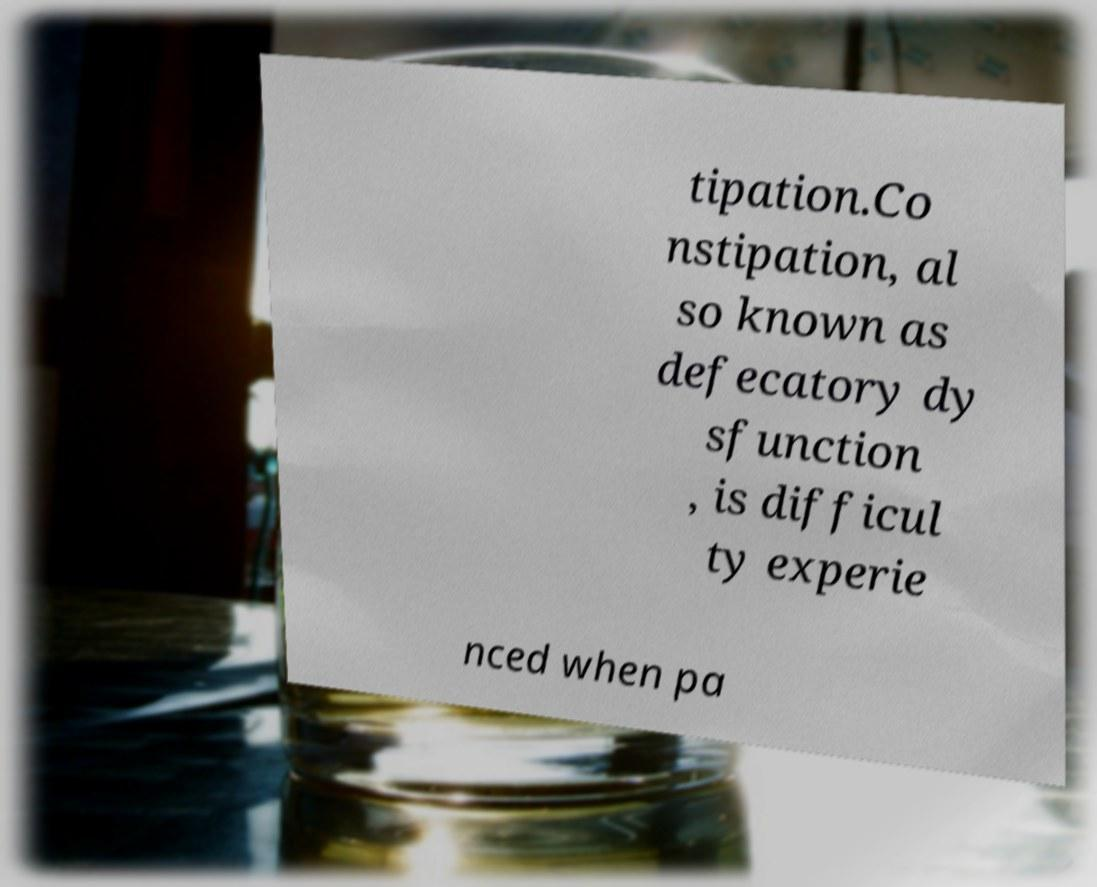Could you extract and type out the text from this image? tipation.Co nstipation, al so known as defecatory dy sfunction , is difficul ty experie nced when pa 